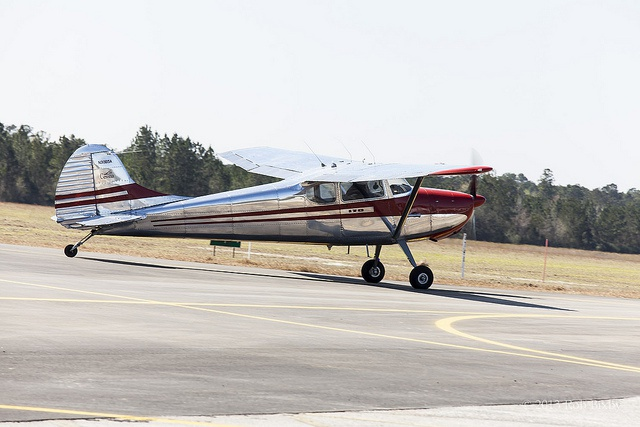Describe the objects in this image and their specific colors. I can see a airplane in white, black, lightgray, darkgray, and gray tones in this image. 